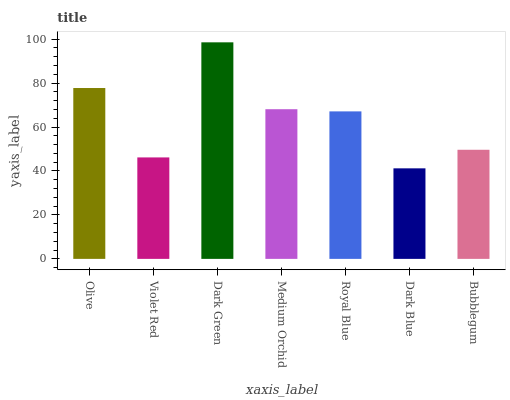Is Violet Red the minimum?
Answer yes or no. No. Is Violet Red the maximum?
Answer yes or no. No. Is Olive greater than Violet Red?
Answer yes or no. Yes. Is Violet Red less than Olive?
Answer yes or no. Yes. Is Violet Red greater than Olive?
Answer yes or no. No. Is Olive less than Violet Red?
Answer yes or no. No. Is Royal Blue the high median?
Answer yes or no. Yes. Is Royal Blue the low median?
Answer yes or no. Yes. Is Medium Orchid the high median?
Answer yes or no. No. Is Olive the low median?
Answer yes or no. No. 